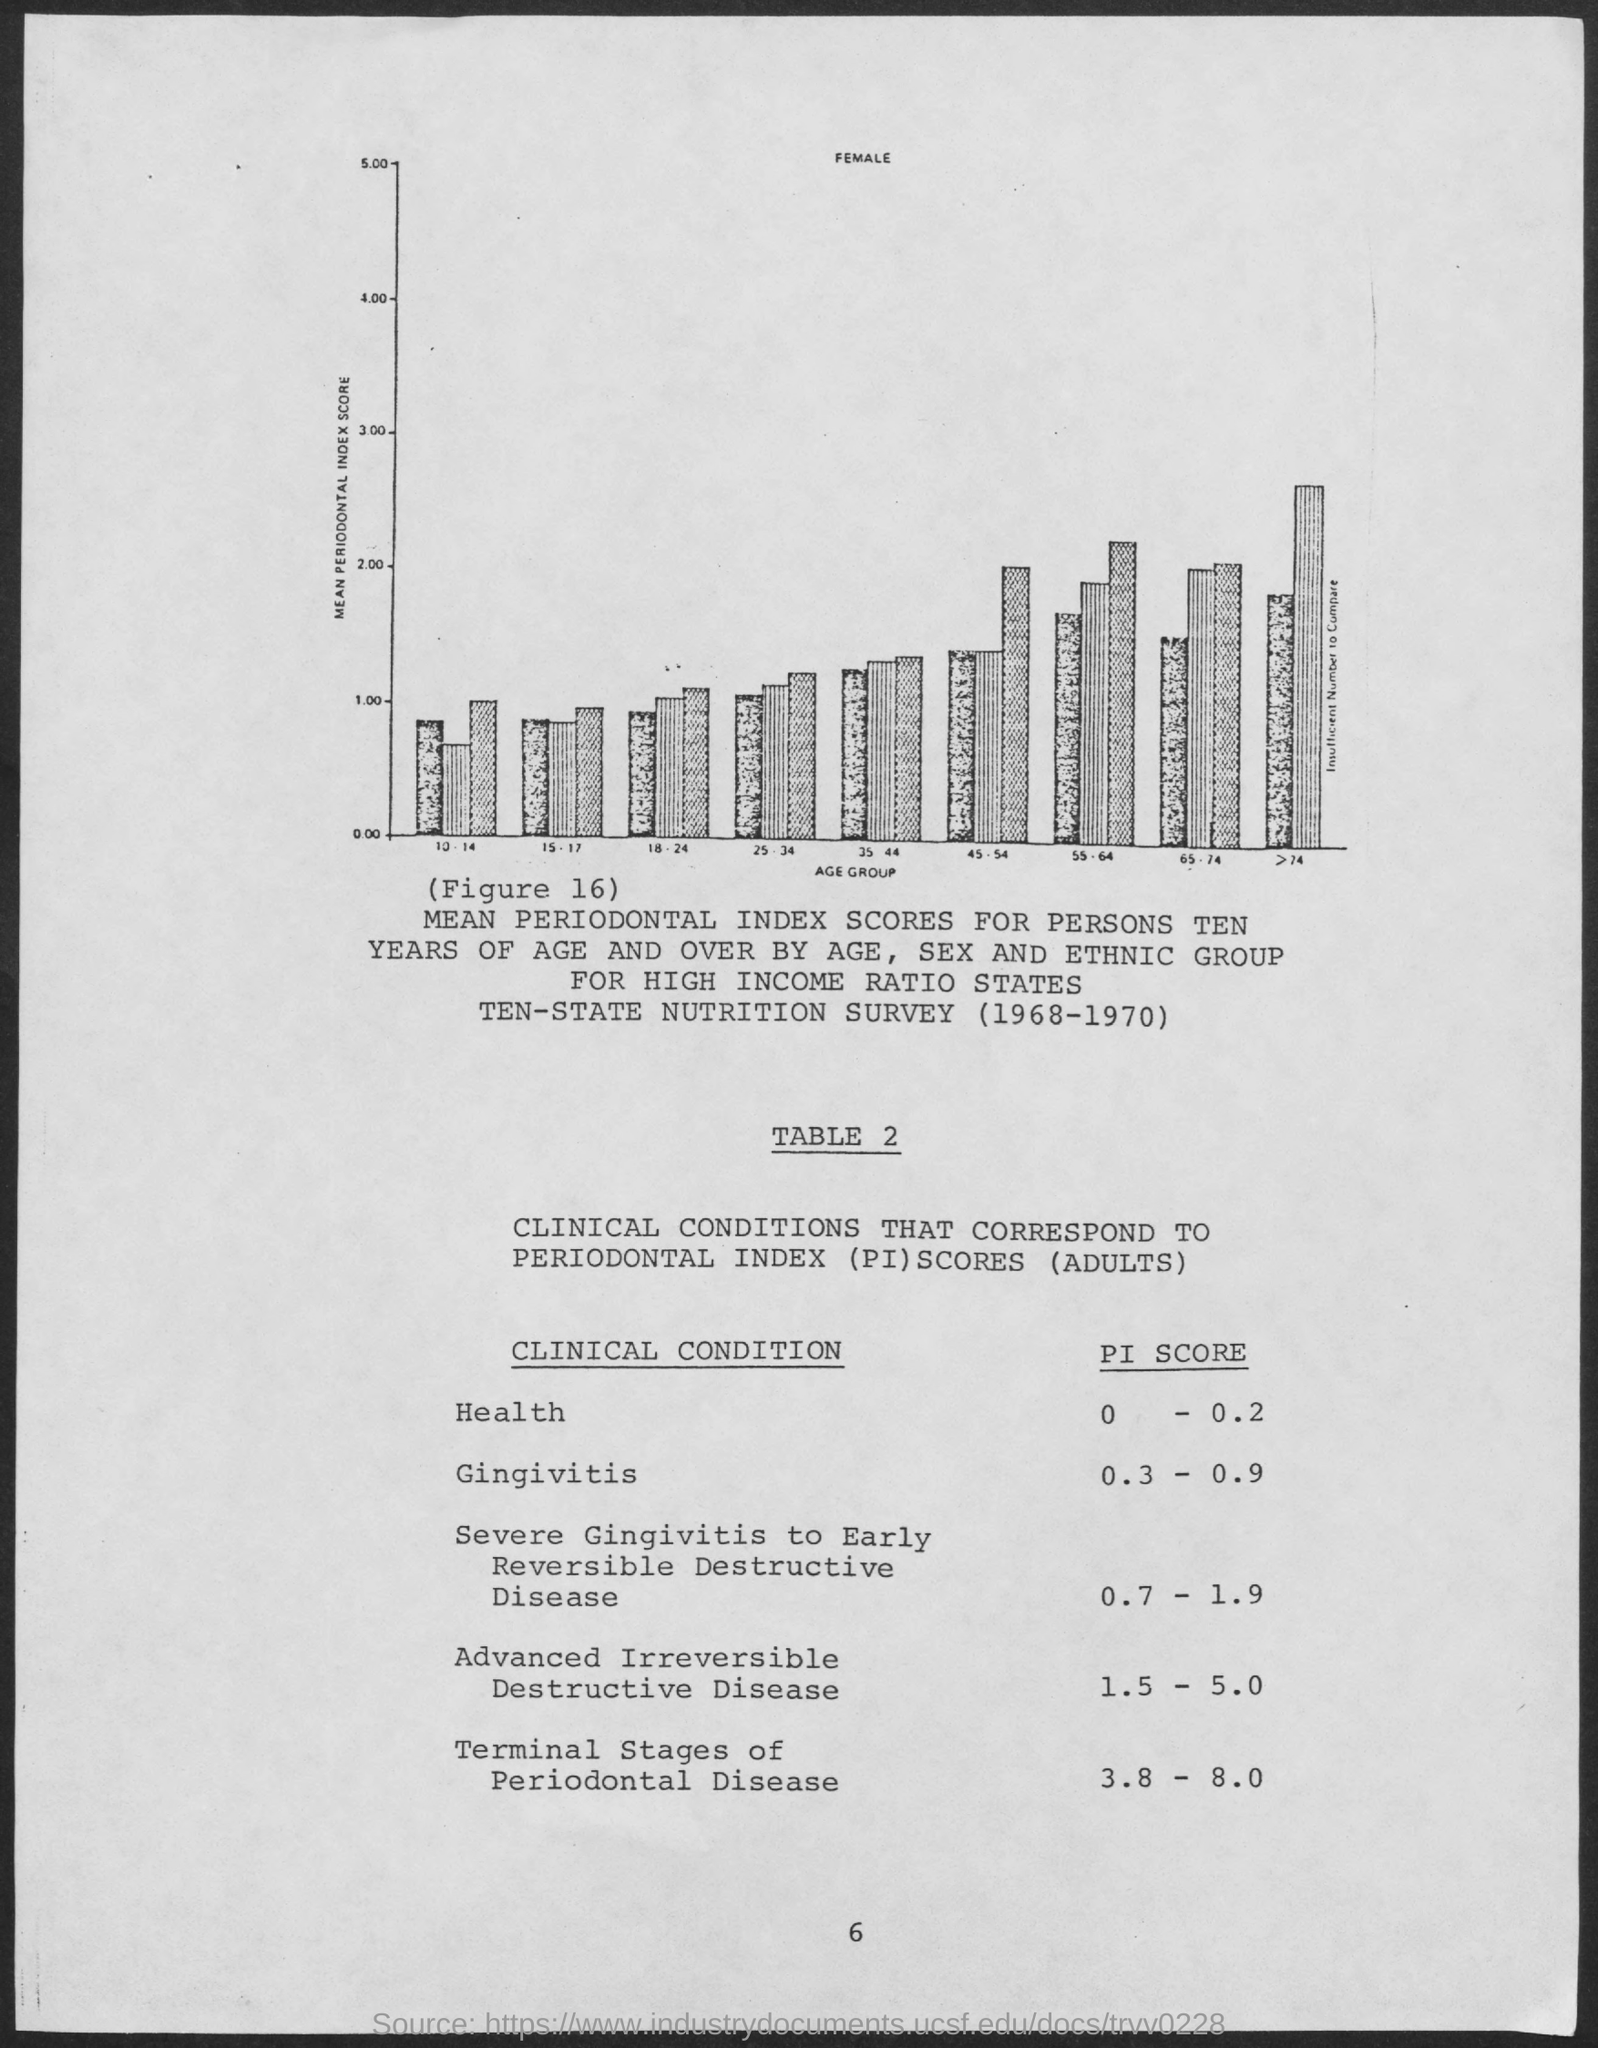What is the pi score for health ?
Provide a short and direct response. 0 - 0.2. What is the pi score for gingivitis ?
Offer a very short reply. 0.3 - 0.9. What is the pi score for terminal stages of periodontal disease ?
Ensure brevity in your answer.  3.8 - 8.0. What is the pi score for advanced irreversible destructive disease ?
Your answer should be compact. 1.5 - 5.0. 